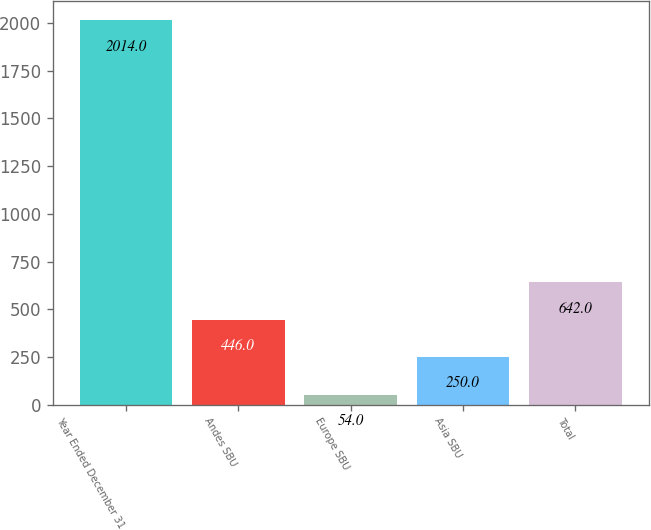Convert chart to OTSL. <chart><loc_0><loc_0><loc_500><loc_500><bar_chart><fcel>Year Ended December 31<fcel>Andes SBU<fcel>Europe SBU<fcel>Asia SBU<fcel>Total<nl><fcel>2014<fcel>446<fcel>54<fcel>250<fcel>642<nl></chart> 